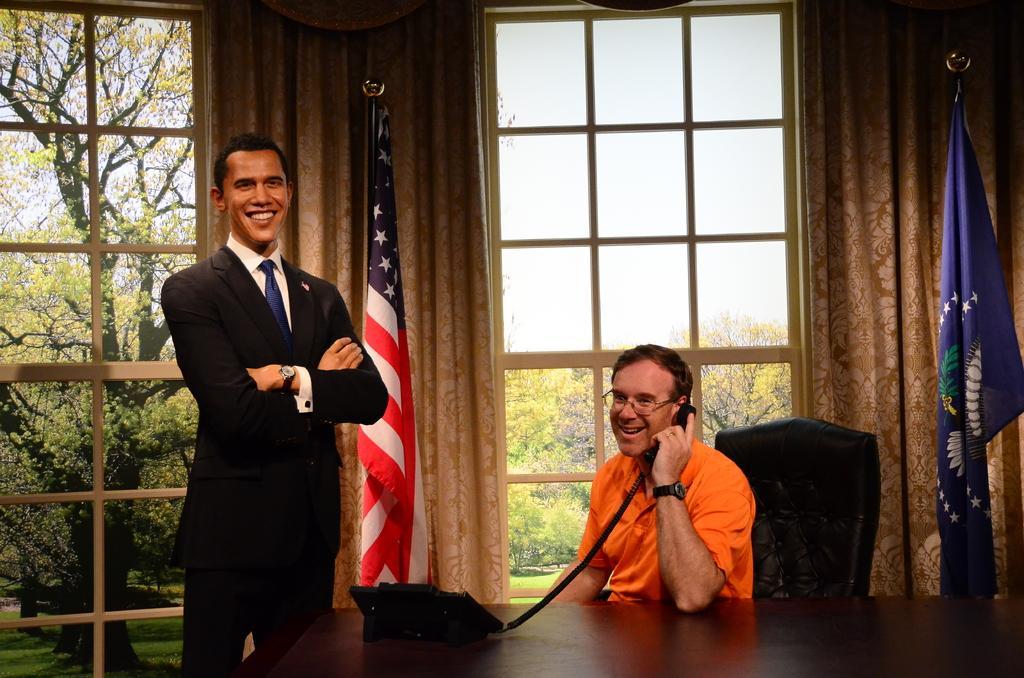In one or two sentences, can you explain what this image depicts? This picture shows a man seated on the chair and holding a telephone receiver and we see a table and couple of curtains to the windows and we see a statue of a man and we see trees from the glass windows and we see a cloudy sky. This picture shows a man wore spectacles on his face and he wore a orange color t-shirt. 